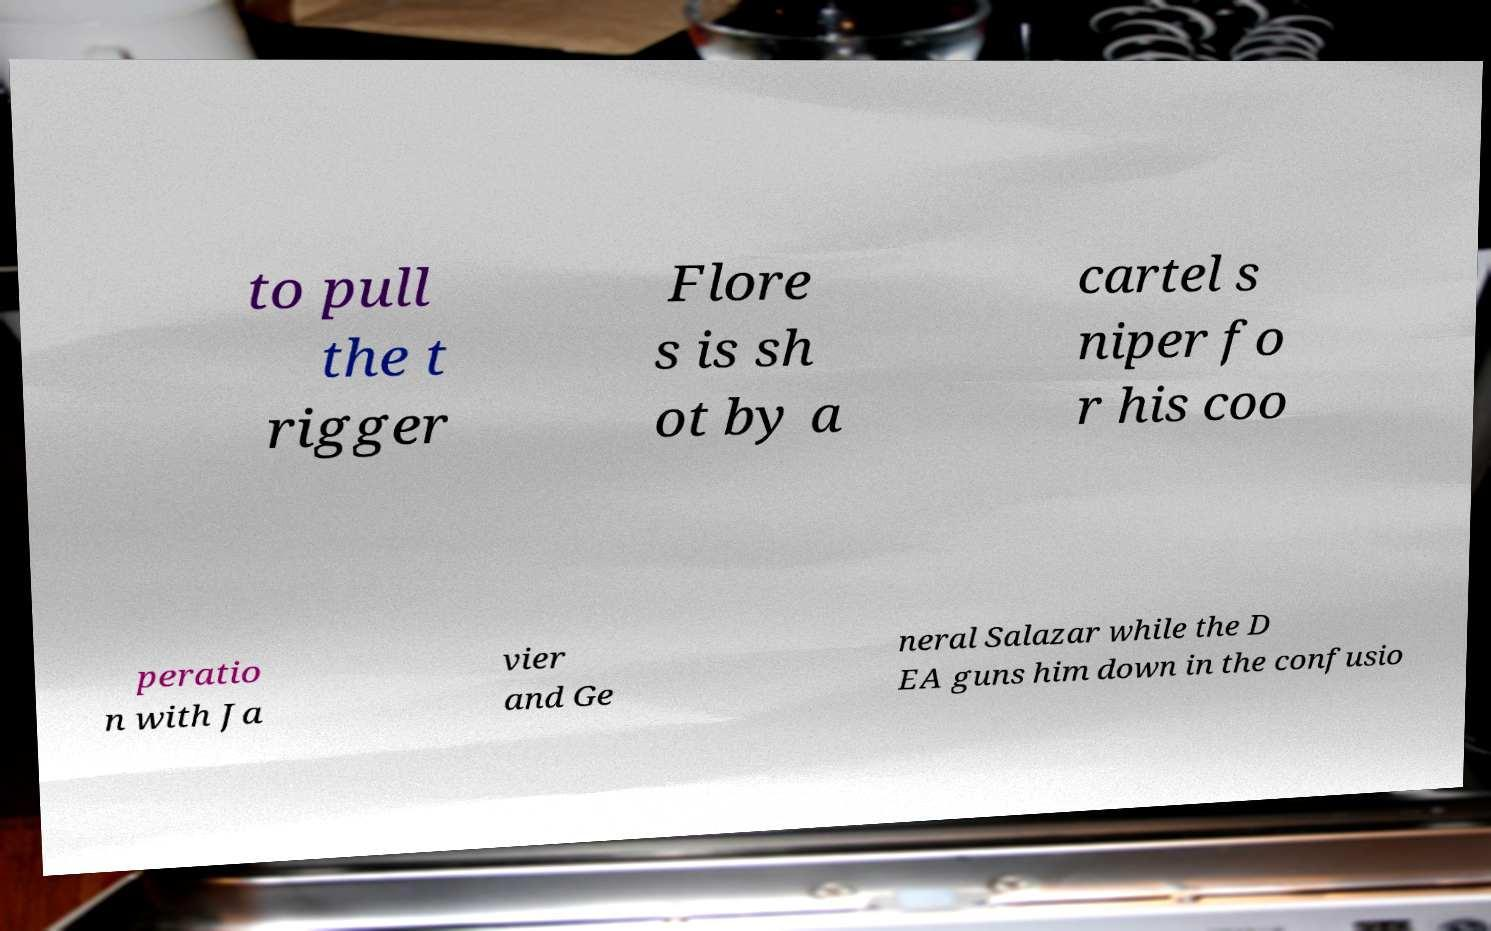Could you extract and type out the text from this image? to pull the t rigger Flore s is sh ot by a cartel s niper fo r his coo peratio n with Ja vier and Ge neral Salazar while the D EA guns him down in the confusio 